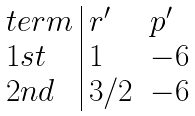<formula> <loc_0><loc_0><loc_500><loc_500>\begin{array} { l | l l } t e r m & r ^ { \prime } & p ^ { \prime } \\ 1 s t & 1 & - 6 \\ 2 n d & 3 / 2 & - 6 \end{array}</formula> 